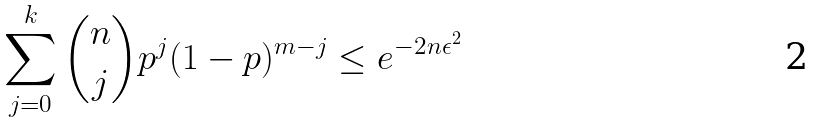Convert formula to latex. <formula><loc_0><loc_0><loc_500><loc_500>\sum _ { j = 0 } ^ { k } { n \choose j } p ^ { j } ( 1 - p ) ^ { m - j } \leq e ^ { - 2 n \epsilon ^ { 2 } }</formula> 